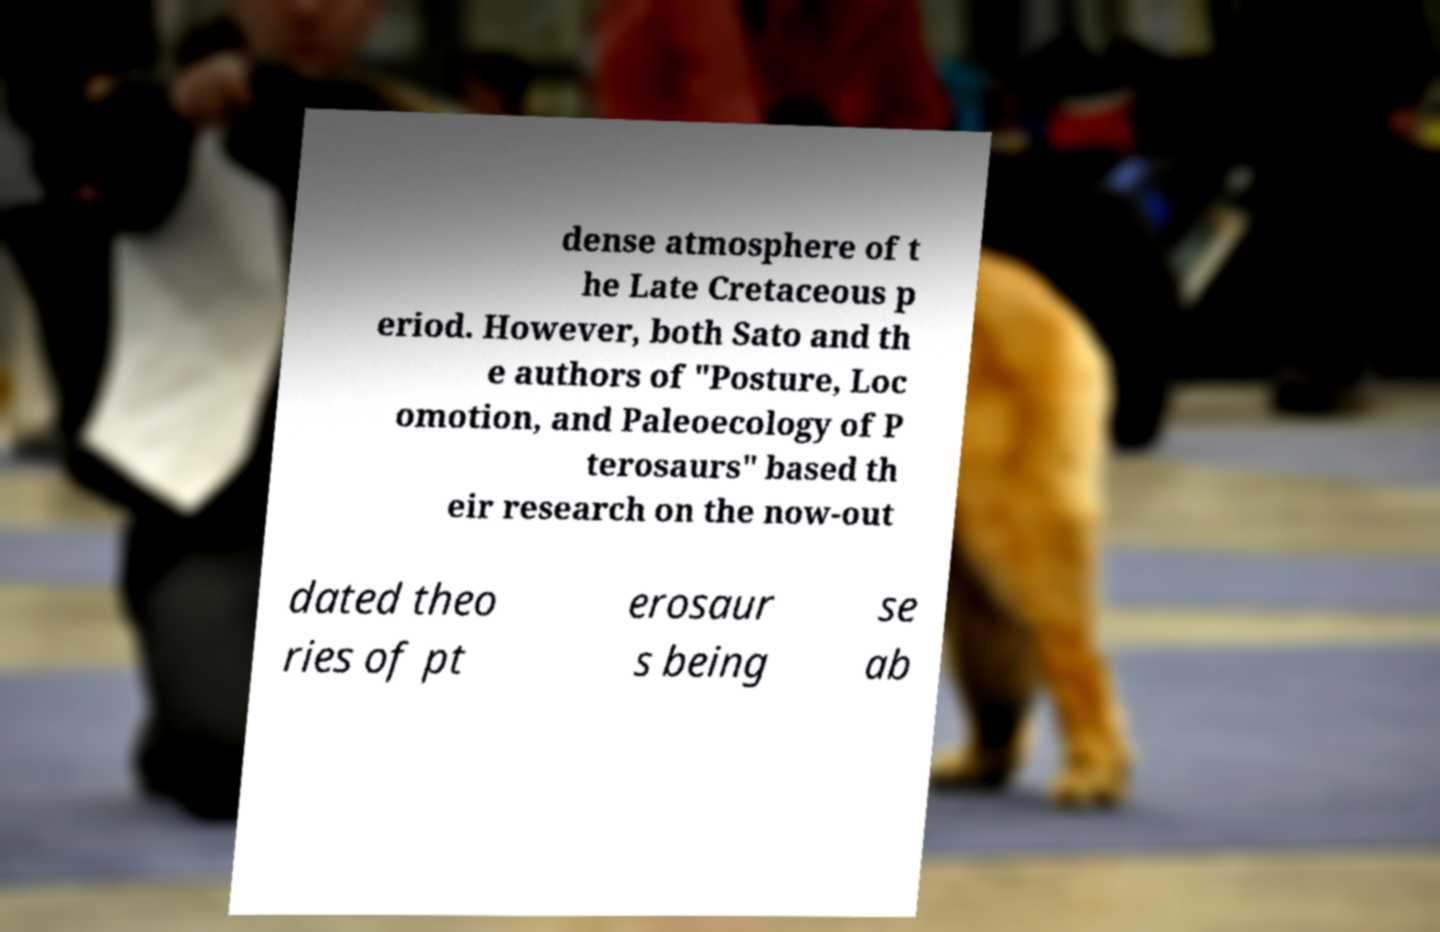Can you read and provide the text displayed in the image?This photo seems to have some interesting text. Can you extract and type it out for me? dense atmosphere of t he Late Cretaceous p eriod. However, both Sato and th e authors of "Posture, Loc omotion, and Paleoecology of P terosaurs" based th eir research on the now-out dated theo ries of pt erosaur s being se ab 